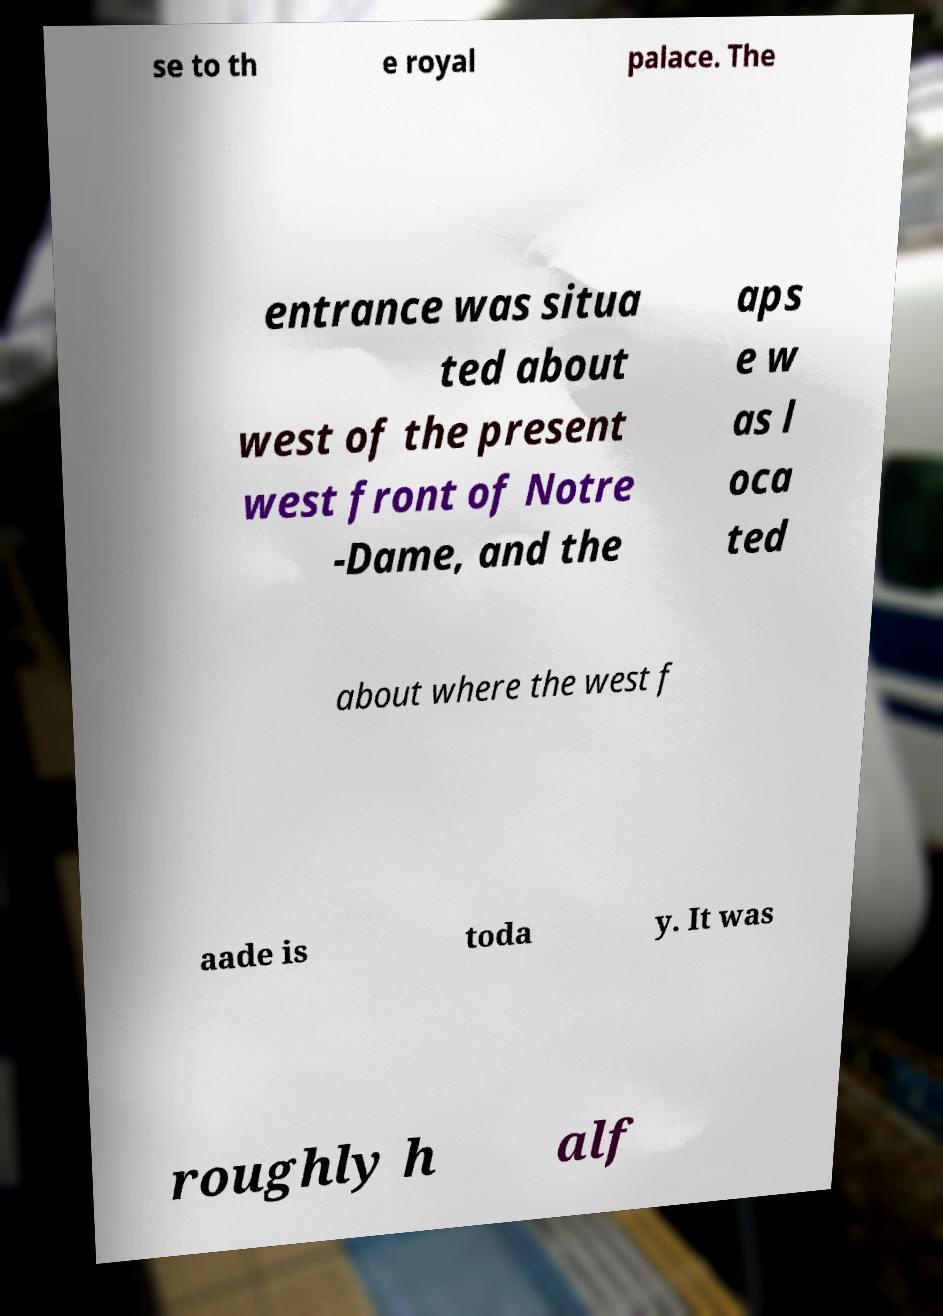Please read and relay the text visible in this image. What does it say? se to th e royal palace. The entrance was situa ted about west of the present west front of Notre -Dame, and the aps e w as l oca ted about where the west f aade is toda y. It was roughly h alf 